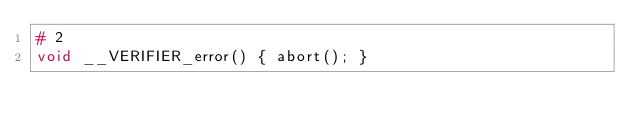<code> <loc_0><loc_0><loc_500><loc_500><_C_># 2
void __VERIFIER_error() { abort(); }
</code> 